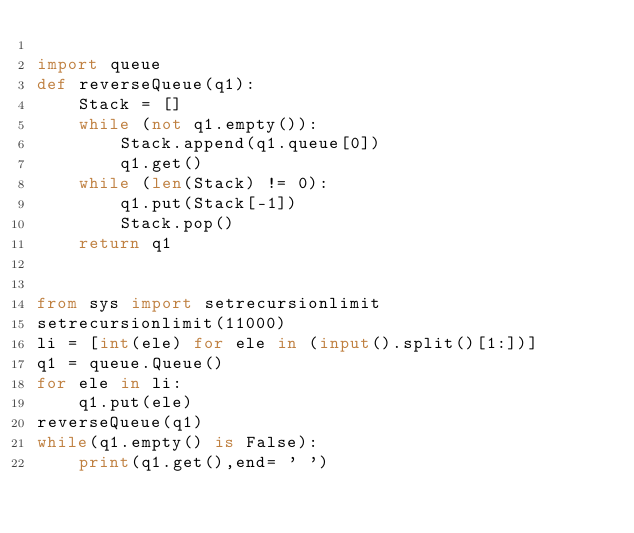Convert code to text. <code><loc_0><loc_0><loc_500><loc_500><_Python_>
import queue
def reverseQueue(q1):
    Stack = []
    while (not q1.empty()):
        Stack.append(q1.queue[0])
        q1.get()
    while (len(Stack) != 0):
        q1.put(Stack[-1])
        Stack.pop()
    return q1
        

from sys import setrecursionlimit
setrecursionlimit(11000)
li = [int(ele) for ele in (input().split()[1:])]
q1 = queue.Queue()
for ele in li:
    q1.put(ele)
reverseQueue(q1)
while(q1.empty() is False):
    print(q1.get(),end= ' ')</code> 